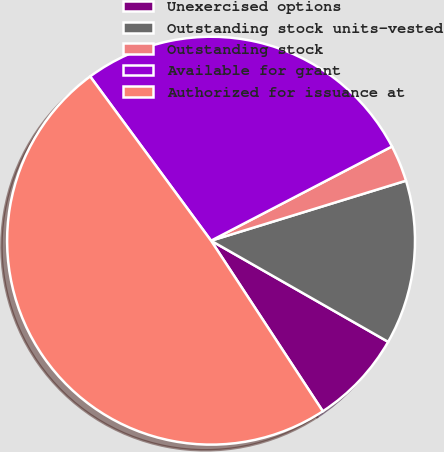Convert chart. <chart><loc_0><loc_0><loc_500><loc_500><pie_chart><fcel>Unexercised options<fcel>Outstanding stock units-vested<fcel>Outstanding stock<fcel>Available for grant<fcel>Authorized for issuance at<nl><fcel>7.51%<fcel>13.01%<fcel>2.89%<fcel>27.46%<fcel>49.13%<nl></chart> 